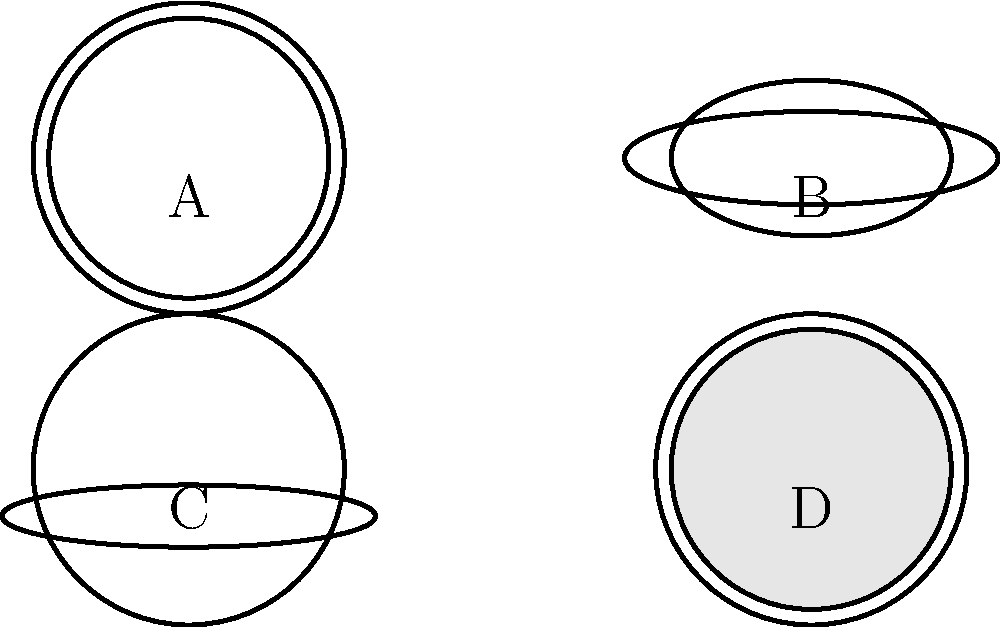Which cooking method is most likely associated with the pot or pan labeled 'C'? To identify the cooking method associated with pot 'C', let's analyze each shape:

1. Shape A: A deep pot with straight sides, typically used for boiling or simmering.
2. Shape B: A shallow pan with sloped sides, often used for frying or sautéing.
3. Shape C: A wide, shallow pot with a fitted lid, characteristic of a Dutch oven.
4. Shape D: A pot filled with something, possibly representing a slow cooker or pressure cooker.

The pot labeled 'C' has these key features:
- Wide and shallow base
- Fitted lid
- Thick walls (implied by the double lines)

These features are typical of a Dutch oven, which is versatile and commonly used for:
1. Braising: slow-cooking meat and vegetables in liquid
2. Roasting: cooking food in dry heat, often in an oven
3. Baking: particularly for bread, as it can trap steam

Among these methods, braising is the most distinctive and frequently associated with Dutch ovens. It involves first searing meat on high heat, then cooking it slowly in a small amount of liquid, which is perfect for the shape and properties of pot 'C'.
Answer: Braising 